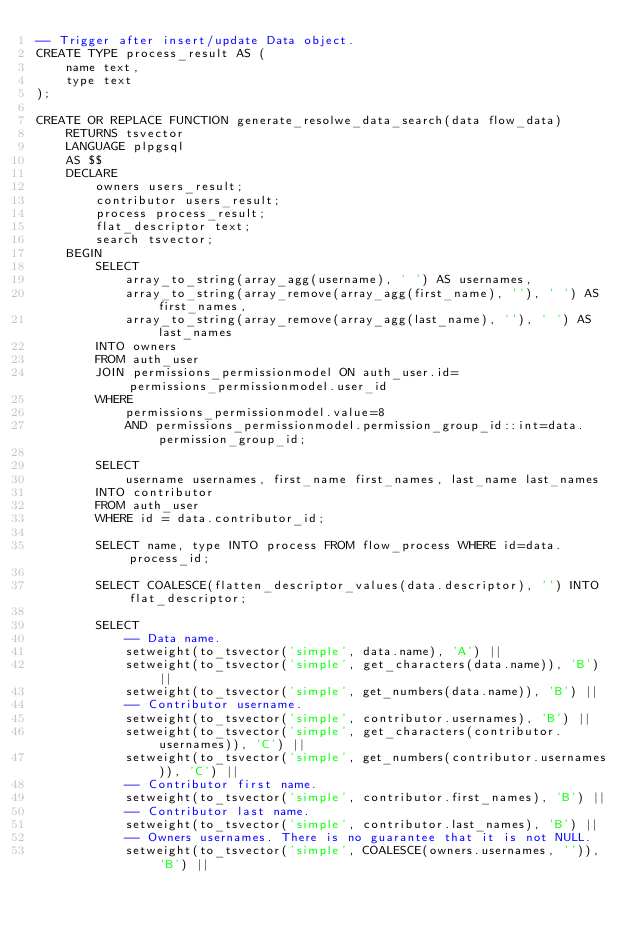Convert code to text. <code><loc_0><loc_0><loc_500><loc_500><_SQL_>-- Trigger after insert/update Data object.
CREATE TYPE process_result AS (
    name text,
    type text
);

CREATE OR REPLACE FUNCTION generate_resolwe_data_search(data flow_data)
    RETURNS tsvector
    LANGUAGE plpgsql
    AS $$
    DECLARE
        owners users_result;
        contributor users_result;
        process process_result;
        flat_descriptor text;
        search tsvector;
    BEGIN
        SELECT
            array_to_string(array_agg(username), ' ') AS usernames,
            array_to_string(array_remove(array_agg(first_name), ''), ' ') AS first_names,
            array_to_string(array_remove(array_agg(last_name), ''), ' ') AS last_names
        INTO owners
        FROM auth_user
        JOIN permissions_permissionmodel ON auth_user.id=permissions_permissionmodel.user_id
        WHERE
            permissions_permissionmodel.value=8
            AND permissions_permissionmodel.permission_group_id::int=data.permission_group_id;

        SELECT
            username usernames, first_name first_names, last_name last_names
        INTO contributor
        FROM auth_user
        WHERE id = data.contributor_id;

        SELECT name, type INTO process FROM flow_process WHERE id=data.process_id;

        SELECT COALESCE(flatten_descriptor_values(data.descriptor), '') INTO flat_descriptor;

        SELECT
            -- Data name.
            setweight(to_tsvector('simple', data.name), 'A') ||
            setweight(to_tsvector('simple', get_characters(data.name)), 'B') ||
            setweight(to_tsvector('simple', get_numbers(data.name)), 'B') ||
            -- Contributor username.
            setweight(to_tsvector('simple', contributor.usernames), 'B') ||
            setweight(to_tsvector('simple', get_characters(contributor.usernames)), 'C') ||
            setweight(to_tsvector('simple', get_numbers(contributor.usernames)), 'C') ||
            -- Contributor first name.
            setweight(to_tsvector('simple', contributor.first_names), 'B') ||
            -- Contributor last name.
            setweight(to_tsvector('simple', contributor.last_names), 'B') ||
            -- Owners usernames. There is no guarantee that it is not NULL.
            setweight(to_tsvector('simple', COALESCE(owners.usernames, '')), 'B') ||</code> 